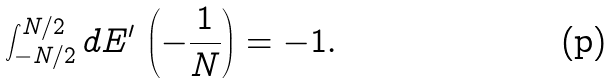<formula> <loc_0><loc_0><loc_500><loc_500>\int _ { - N / 2 } ^ { N / 2 } d E ^ { \prime } \, \left ( - \frac { 1 } { N } \right ) = - 1 .</formula> 